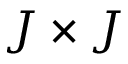<formula> <loc_0><loc_0><loc_500><loc_500>J \times J</formula> 